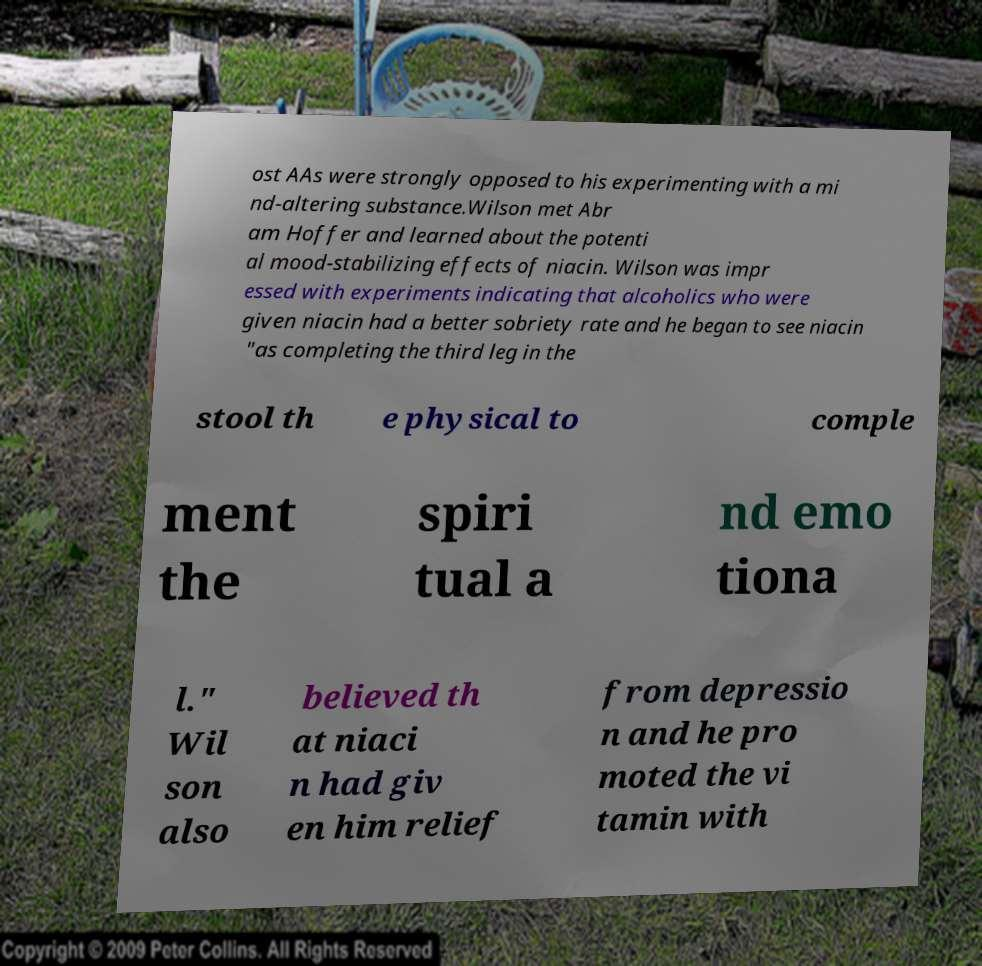Can you read and provide the text displayed in the image?This photo seems to have some interesting text. Can you extract and type it out for me? ost AAs were strongly opposed to his experimenting with a mi nd-altering substance.Wilson met Abr am Hoffer and learned about the potenti al mood-stabilizing effects of niacin. Wilson was impr essed with experiments indicating that alcoholics who were given niacin had a better sobriety rate and he began to see niacin "as completing the third leg in the stool th e physical to comple ment the spiri tual a nd emo tiona l." Wil son also believed th at niaci n had giv en him relief from depressio n and he pro moted the vi tamin with 